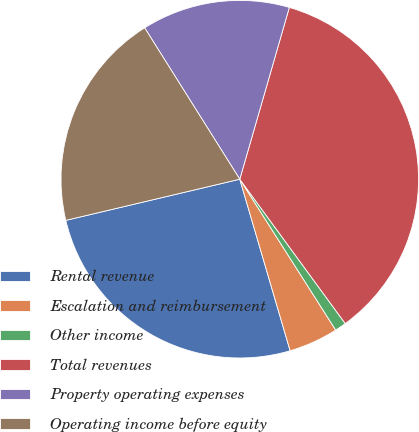Convert chart. <chart><loc_0><loc_0><loc_500><loc_500><pie_chart><fcel>Rental revenue<fcel>Escalation and reimbursement<fcel>Other income<fcel>Total revenues<fcel>Property operating expenses<fcel>Operating income before equity<nl><fcel>25.85%<fcel>4.47%<fcel>1.03%<fcel>35.49%<fcel>13.4%<fcel>19.77%<nl></chart> 